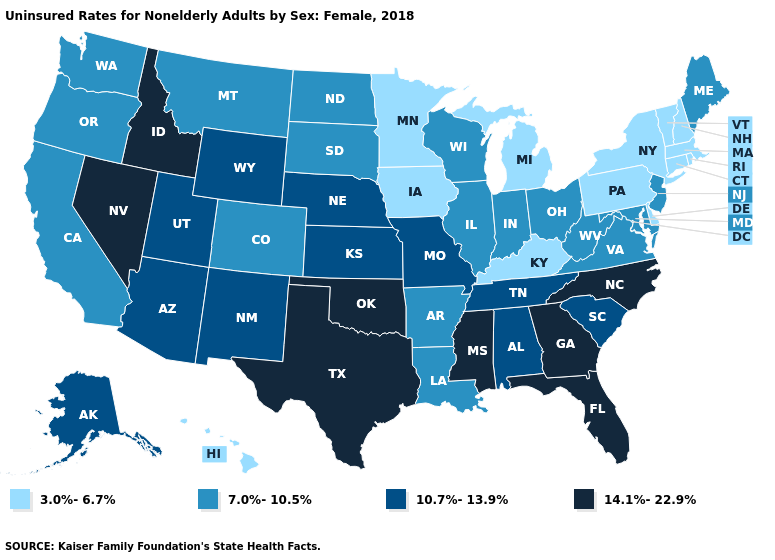Name the states that have a value in the range 7.0%-10.5%?
Short answer required. Arkansas, California, Colorado, Illinois, Indiana, Louisiana, Maine, Maryland, Montana, New Jersey, North Dakota, Ohio, Oregon, South Dakota, Virginia, Washington, West Virginia, Wisconsin. What is the lowest value in states that border South Carolina?
Keep it brief. 14.1%-22.9%. What is the value of Ohio?
Concise answer only. 7.0%-10.5%. Name the states that have a value in the range 14.1%-22.9%?
Keep it brief. Florida, Georgia, Idaho, Mississippi, Nevada, North Carolina, Oklahoma, Texas. Does Pennsylvania have a higher value than Indiana?
Give a very brief answer. No. How many symbols are there in the legend?
Answer briefly. 4. Name the states that have a value in the range 14.1%-22.9%?
Quick response, please. Florida, Georgia, Idaho, Mississippi, Nevada, North Carolina, Oklahoma, Texas. Among the states that border Florida , which have the highest value?
Write a very short answer. Georgia. What is the highest value in the Northeast ?
Keep it brief. 7.0%-10.5%. What is the value of Mississippi?
Quick response, please. 14.1%-22.9%. Name the states that have a value in the range 14.1%-22.9%?
Answer briefly. Florida, Georgia, Idaho, Mississippi, Nevada, North Carolina, Oklahoma, Texas. What is the value of Massachusetts?
Write a very short answer. 3.0%-6.7%. What is the value of Pennsylvania?
Give a very brief answer. 3.0%-6.7%. Name the states that have a value in the range 3.0%-6.7%?
Short answer required. Connecticut, Delaware, Hawaii, Iowa, Kentucky, Massachusetts, Michigan, Minnesota, New Hampshire, New York, Pennsylvania, Rhode Island, Vermont. 